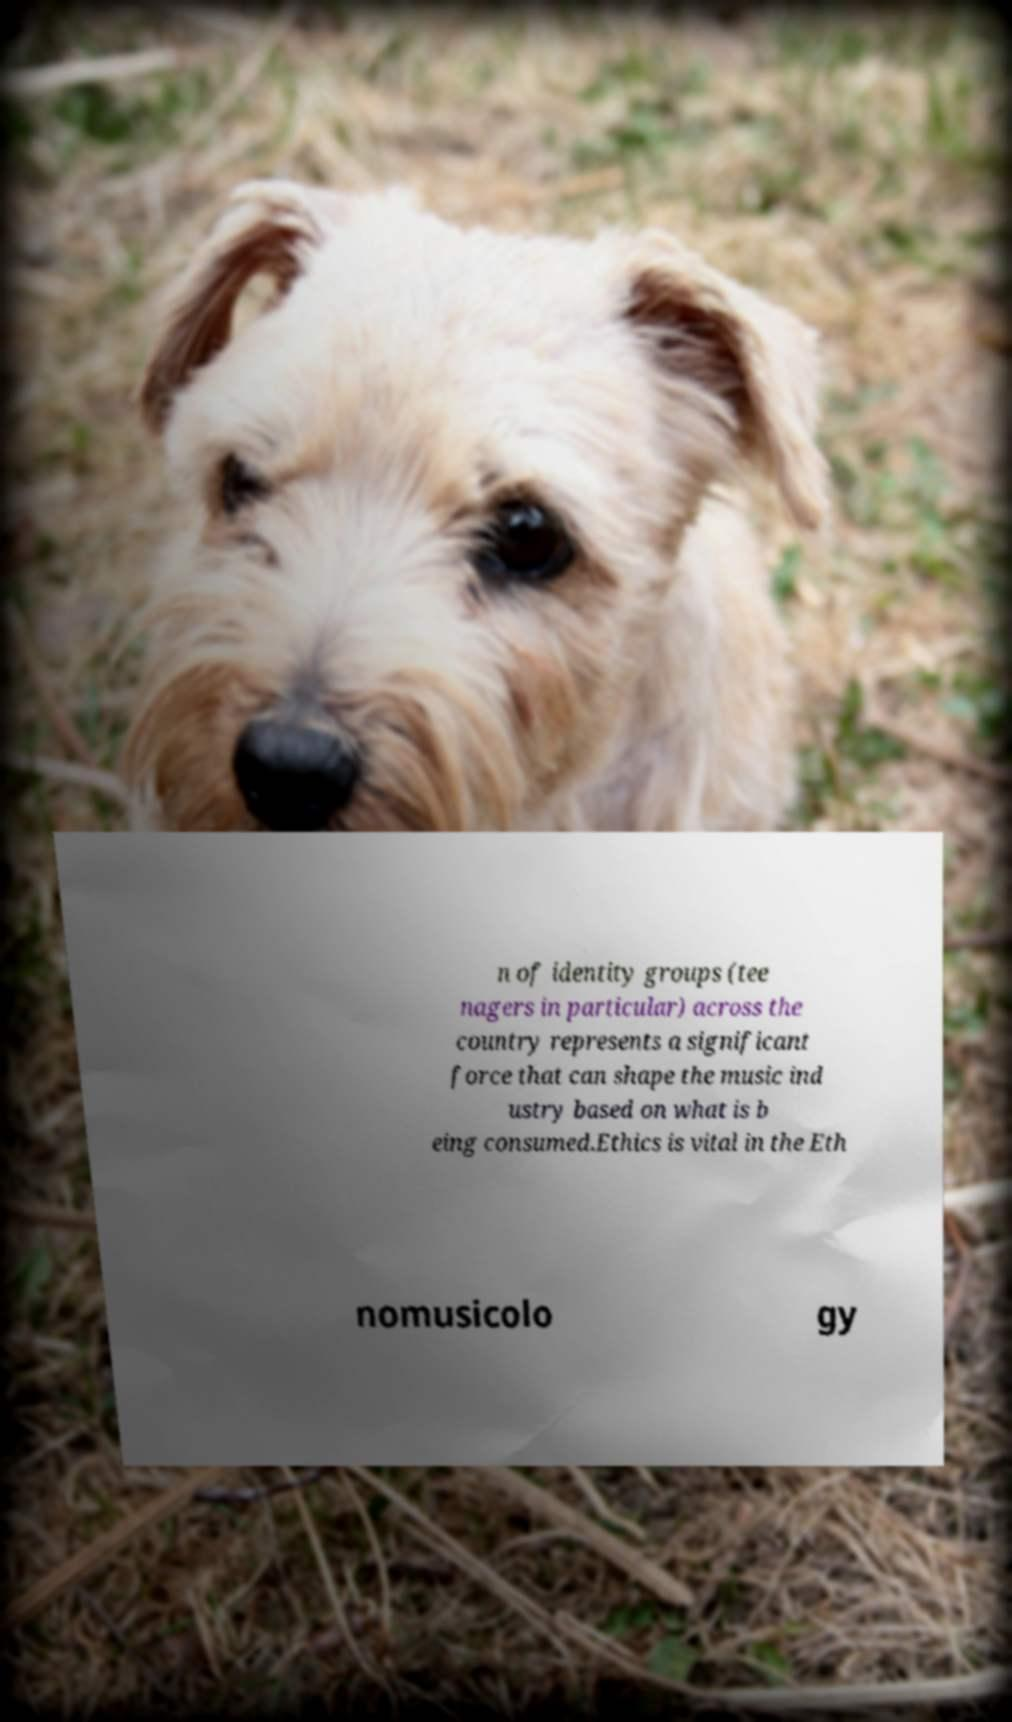Please read and relay the text visible in this image. What does it say? n of identity groups (tee nagers in particular) across the country represents a significant force that can shape the music ind ustry based on what is b eing consumed.Ethics is vital in the Eth nomusicolo gy 